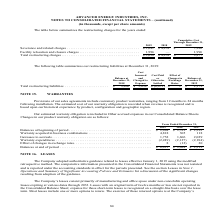According to Advanced Energy's financial document, What were the severance and related charges in 2019? According to the financial document, $3,041 (in thousands). The relevant text states: "2019 2018 2019 Severance and related charges . $ 3,041 $ 4,239 $ 7,280..." Also, What were the Facility relocation and closure charges in 2019? According to the financial document, 1,996 (in thousands). The relevant text states: "Facility relocation and closure charges . 1,996 — 1,996 Total restructuring charges . $ 5,038 $ 4,239 $ 9,277..." Also, What was the total restructuring charges in 2018? According to the financial document, $4,239 (in thousands). The relevant text states: "18 2019 Severance and related charges . $ 3,041 $ 4,239 $ 7,280..." Also, can you calculate: What was the change in Severance and related charges between 2018 and 2019? Based on the calculation: 3,041-4,239, the result is -1198 (in thousands). This is based on the information: "18 2019 Severance and related charges . $ 3,041 $ 4,239 $ 7,280 2019 2018 2019 Severance and related charges . $ 3,041 $ 4,239 $ 7,280..." The key data points involved are: 3,041, 4,239. Also, can you calculate: What percentage of total restructuring charges in 2019 consisted of Facility relocation and closure charges? Based on the calculation: 1,996/5,038, the result is 39.62 (percentage). This is based on the information: "s . 1,996 — 1,996 Total restructuring charges . $ 5,038 $ 4,239 $ 9,277 Facility relocation and closure charges . 1,996 — 1,996 Total restructuring charges . $ 5,038 $ 4,239 $ 9,277..." The key data points involved are: 1,996, 5,038. Also, can you calculate: What was the percentage change in total restructuring charges between 2018 and 2019? To answer this question, I need to perform calculations using the financial data. The calculation is: ($5,038-$4,239)/$4,239, which equals 18.85 (percentage). This is based on the information: "s . 1,996 — 1,996 Total restructuring charges . $ 5,038 $ 4,239 $ 9,277 18 2019 Severance and related charges . $ 3,041 $ 4,239 $ 7,280..." The key data points involved are: 4,239, 5,038. 